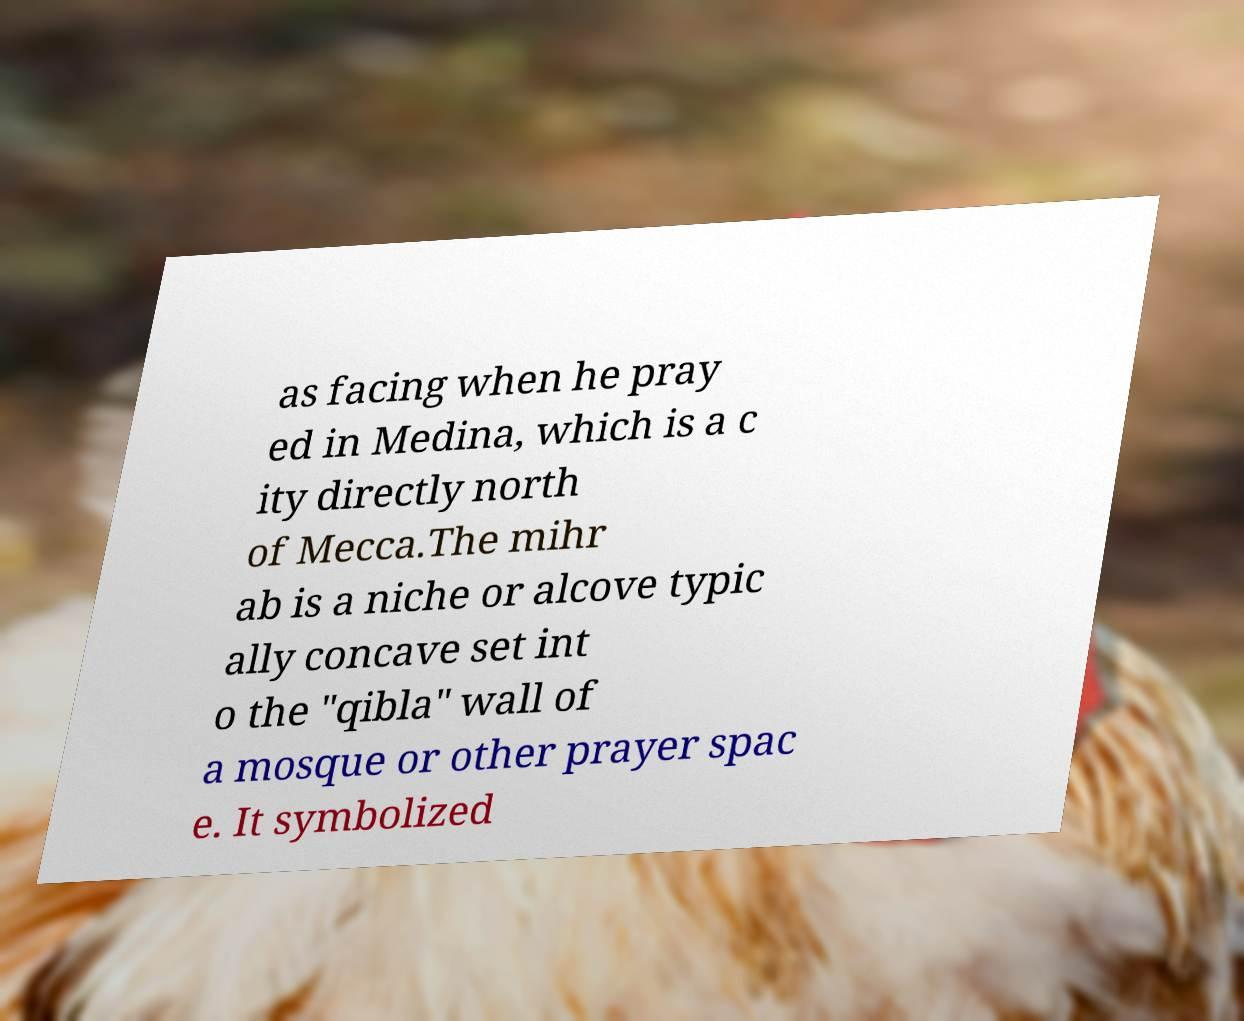Can you accurately transcribe the text from the provided image for me? as facing when he pray ed in Medina, which is a c ity directly north of Mecca.The mihr ab is a niche or alcove typic ally concave set int o the "qibla" wall of a mosque or other prayer spac e. It symbolized 